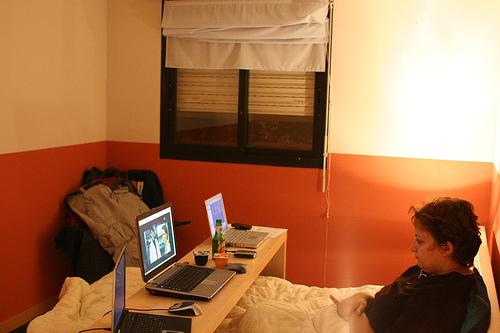What is the number of laptops sat on the bar held over this bed? Please explain your reasoning. three. There are three laptops on the desk that this person is sitting in front of. 